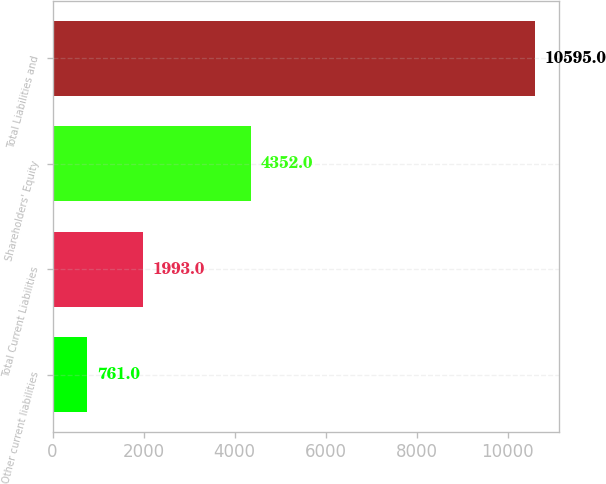<chart> <loc_0><loc_0><loc_500><loc_500><bar_chart><fcel>Other current liabilities<fcel>Total Current Liabilities<fcel>Shareholders' Equity<fcel>Total Liabilities and<nl><fcel>761<fcel>1993<fcel>4352<fcel>10595<nl></chart> 